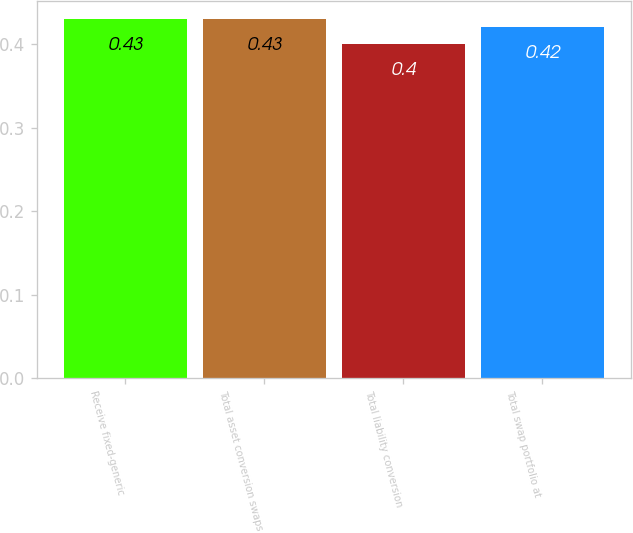Convert chart to OTSL. <chart><loc_0><loc_0><loc_500><loc_500><bar_chart><fcel>Receive fixed-generic<fcel>Total asset conversion swaps<fcel>Total liability conversion<fcel>Total swap portfolio at<nl><fcel>0.43<fcel>0.43<fcel>0.4<fcel>0.42<nl></chart> 